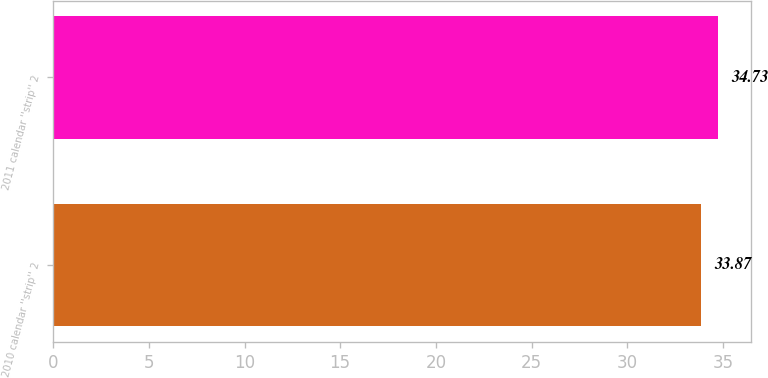Convert chart to OTSL. <chart><loc_0><loc_0><loc_500><loc_500><bar_chart><fcel>2010 calendar ''strip'' 2<fcel>2011 calendar ''strip'' 2<nl><fcel>33.87<fcel>34.73<nl></chart> 